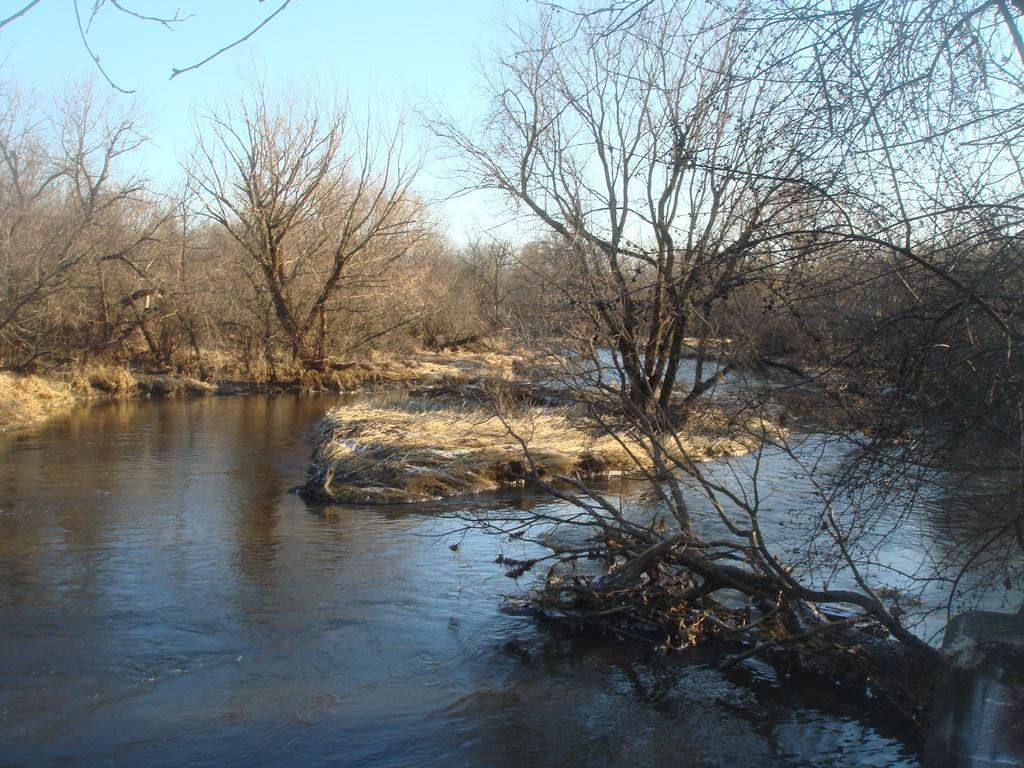What is visible in the image? There is water and trees visible in the image. Can you describe the water in the image? The water is visible, but its specific characteristics are not mentioned in the provided facts. What type of vegetation is present in the image? Trees are present in the image. What is the belief of the kittens in the image? There are no kittens present in the image, so their beliefs cannot be determined. 